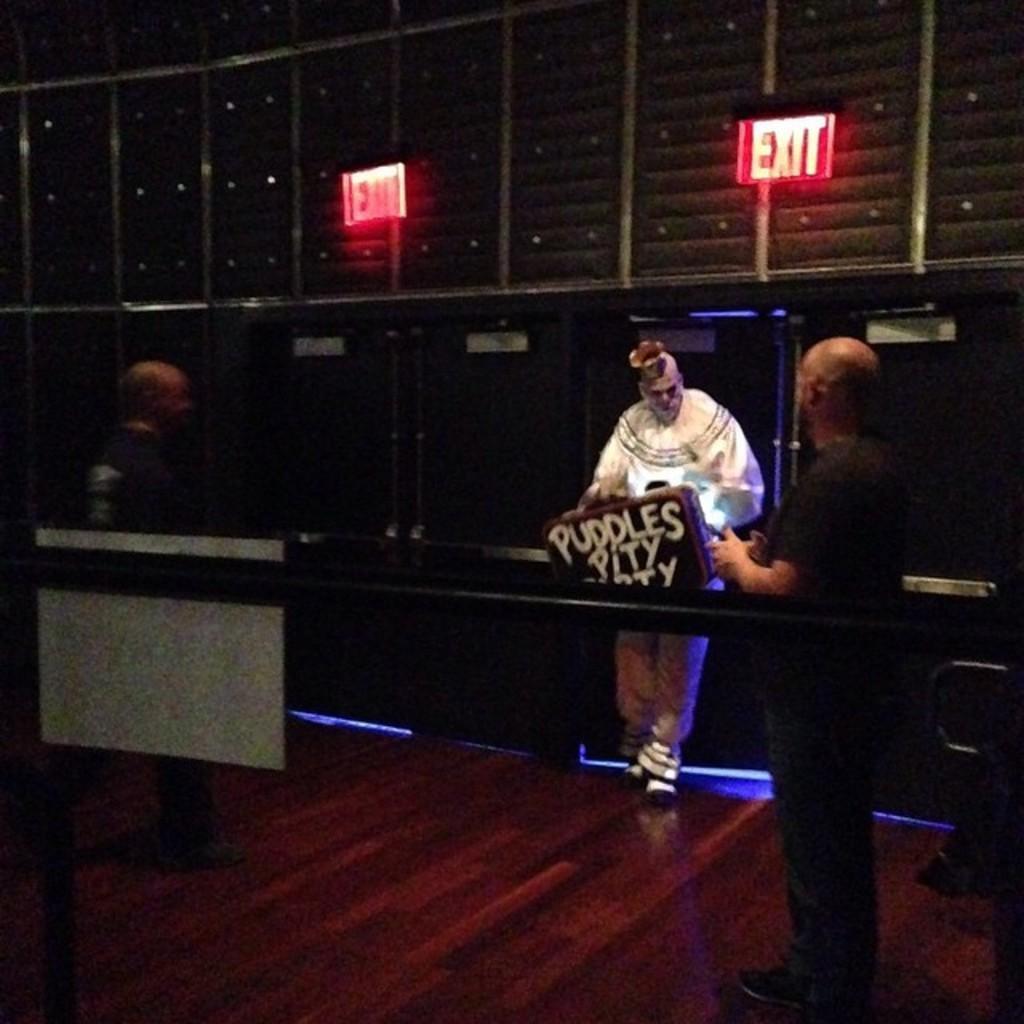Could you give a brief overview of what you see in this image? In this image I can see three people with the dress and I can see an object and something is written on it. In the background I can see the LED boards to the wall. 